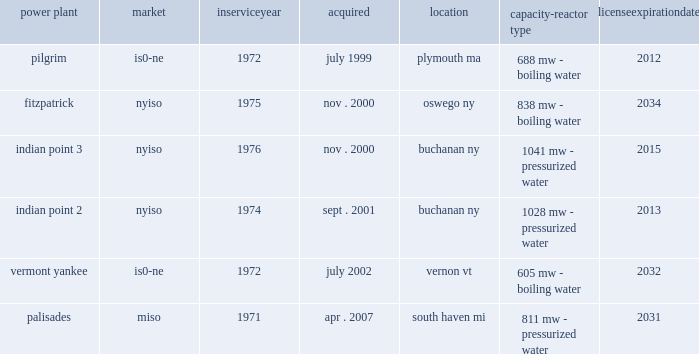Part i item 1 entergy corporation , utility operating companies , and system energy entergy wholesale commodities during 2010 entergy integrated its non-utility nuclear and its non-nuclear wholesale assets businesses into a new organization called entergy wholesale commodities .
Entergy wholesale commodities includes the ownership and operation of six nuclear power plants , five of which are located in the northeast united states , with the sixth located in michigan , and is primarily focused on selling electric power produced by those plants to wholesale customers .
Entergy wholesale commodities 2019 revenues are primarily derived from sales of energy and generation capacity from these plants .
Entergy wholesale commodities also provides operations and management services , including decommissioning services , to nuclear power plants owned by other utilities in the united states .
Entergy wholesale commodities also includes the ownership of , or participation in joint ventures that own , non-nuclear power plants and the sale to wholesale customers of the electric power produced by these plants .
Property nuclear generating stations entergy wholesale commodities includes the ownership of the following nuclear power plants : power plant market service acquired location capacity- reactor type license expiration .
Entergy wholesale commodities also includes the ownership of two non-operating nuclear facilities , big rock point in michigan and indian point 1 in new york that were acquired when entergy purchased the palisades and indian point 2 nuclear plants , respectively .
These facilities are in various stages of the decommissioning process .
The nrc operating license for vermont yankee was to expire in march 2012 .
In march 2011 the nrc renewed vermont yankee 2019s operating license for an additional 20 years , as a result of which the license now expires in 2032 .
For additional discussion regarding the continued operation of the vermont yankee plant , see 201cimpairment of long-lived assets 201d in note 1 to the financial statements .
The operating licenses for pilgrim , indian point 2 , and indian point 3 expire between 2012 and 2015 .
Under federal law , nuclear power plants may continue to operate beyond their license expiration dates while their renewal applications are pending nrc approval .
Various parties have expressed opposition to renewal of the licenses .
With respect to the pilgrim license renewal , the atomic safety and licensing board ( aslb ) of the nrc , after issuing an order denying a new hearing request , terminated its proceeding on pilgrim 2019s license renewal application .
With the aslb process concluded the proceeding , including appeals of certain aslb decisions , is now before the nrc .
In april 2007 , entergy submitted an application to the nrc to renew the operating licenses for indian point 2 and 3 for an additional 20 years .
The aslb has admitted 21 contentions raised by the state of new york or other parties , which were combined into 16 discrete issues .
Two of the issues have been resolved , leaving 14 issues that are currently subject to aslb hearings .
In july 2011 , the aslb granted the state of new york 2019s motion for summary disposition of an admitted contention challenging the adequacy of a section of indian point 2019s environmental analysis as incorporated in the fseis ( discussed below ) .
That section provided cost estimates for severe accident mitigation alternatives ( samas ) , which are hardware and procedural changes that could be .
What is the length of the lease for pilgrim , ( in years ) ? 
Computations: (2012 - 1999)
Answer: 13.0. Part i item 1 entergy corporation , utility operating companies , and system energy entergy wholesale commodities during 2010 entergy integrated its non-utility nuclear and its non-nuclear wholesale assets businesses into a new organization called entergy wholesale commodities .
Entergy wholesale commodities includes the ownership and operation of six nuclear power plants , five of which are located in the northeast united states , with the sixth located in michigan , and is primarily focused on selling electric power produced by those plants to wholesale customers .
Entergy wholesale commodities 2019 revenues are primarily derived from sales of energy and generation capacity from these plants .
Entergy wholesale commodities also provides operations and management services , including decommissioning services , to nuclear power plants owned by other utilities in the united states .
Entergy wholesale commodities also includes the ownership of , or participation in joint ventures that own , non-nuclear power plants and the sale to wholesale customers of the electric power produced by these plants .
Property nuclear generating stations entergy wholesale commodities includes the ownership of the following nuclear power plants : power plant market service acquired location capacity- reactor type license expiration .
Entergy wholesale commodities also includes the ownership of two non-operating nuclear facilities , big rock point in michigan and indian point 1 in new york that were acquired when entergy purchased the palisades and indian point 2 nuclear plants , respectively .
These facilities are in various stages of the decommissioning process .
The nrc operating license for vermont yankee was to expire in march 2012 .
In march 2011 the nrc renewed vermont yankee 2019s operating license for an additional 20 years , as a result of which the license now expires in 2032 .
For additional discussion regarding the continued operation of the vermont yankee plant , see 201cimpairment of long-lived assets 201d in note 1 to the financial statements .
The operating licenses for pilgrim , indian point 2 , and indian point 3 expire between 2012 and 2015 .
Under federal law , nuclear power plants may continue to operate beyond their license expiration dates while their renewal applications are pending nrc approval .
Various parties have expressed opposition to renewal of the licenses .
With respect to the pilgrim license renewal , the atomic safety and licensing board ( aslb ) of the nrc , after issuing an order denying a new hearing request , terminated its proceeding on pilgrim 2019s license renewal application .
With the aslb process concluded the proceeding , including appeals of certain aslb decisions , is now before the nrc .
In april 2007 , entergy submitted an application to the nrc to renew the operating licenses for indian point 2 and 3 for an additional 20 years .
The aslb has admitted 21 contentions raised by the state of new york or other parties , which were combined into 16 discrete issues .
Two of the issues have been resolved , leaving 14 issues that are currently subject to aslb hearings .
In july 2011 , the aslb granted the state of new york 2019s motion for summary disposition of an admitted contention challenging the adequacy of a section of indian point 2019s environmental analysis as incorporated in the fseis ( discussed below ) .
That section provided cost estimates for severe accident mitigation alternatives ( samas ) , which are hardware and procedural changes that could be .
What is the length of the lease for fitzpatrick , ( in years ) ? 
Computations: (2034 - 2000)
Answer: 34.0. 